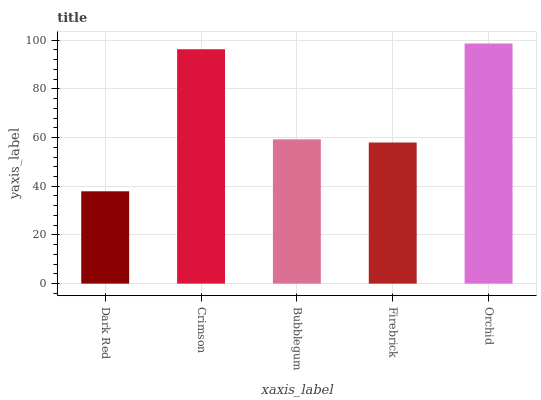Is Crimson the minimum?
Answer yes or no. No. Is Crimson the maximum?
Answer yes or no. No. Is Crimson greater than Dark Red?
Answer yes or no. Yes. Is Dark Red less than Crimson?
Answer yes or no. Yes. Is Dark Red greater than Crimson?
Answer yes or no. No. Is Crimson less than Dark Red?
Answer yes or no. No. Is Bubblegum the high median?
Answer yes or no. Yes. Is Bubblegum the low median?
Answer yes or no. Yes. Is Crimson the high median?
Answer yes or no. No. Is Orchid the low median?
Answer yes or no. No. 